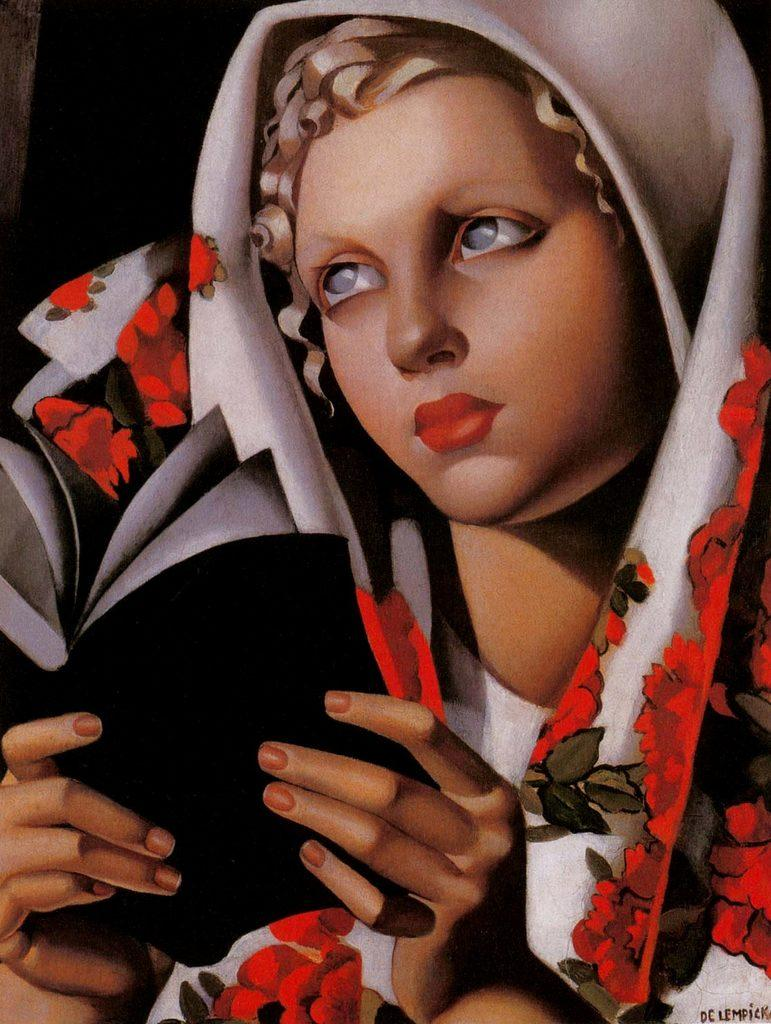What is depicted in the painting in the image? There is a painting of a person in the image. What is the person in the image doing? The person is holding a book in the image. Where can text be found in the image? There is text in the bottom right corner of the image. What type of animal can be seen drinking from a bottle in the image? There is no animal or bottle present in the image. How far does the range of the painting extend in the image? The range of the painting is not applicable in this context, as the painting is a static image and does not have a range. 